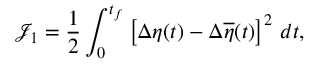<formula> <loc_0><loc_0><loc_500><loc_500>{ \mathcal { J } } _ { 1 } = \frac { 1 } { 2 } \int _ { 0 } ^ { t _ { f } } \left [ \Delta \eta ( t ) - \Delta \overline { \eta } ( t ) \right ] ^ { 2 } \, d t ,</formula> 